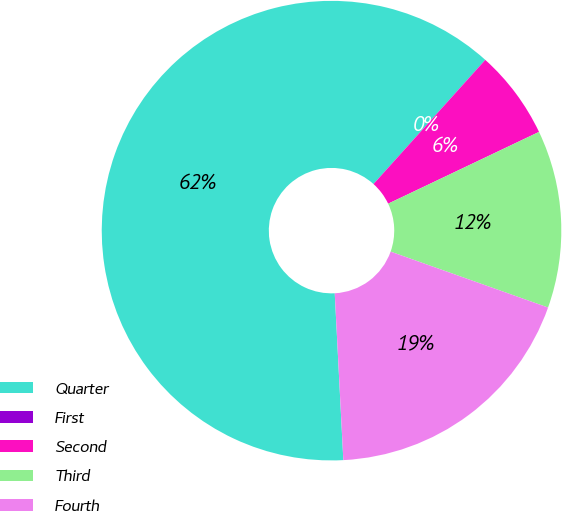Convert chart. <chart><loc_0><loc_0><loc_500><loc_500><pie_chart><fcel>Quarter<fcel>First<fcel>Second<fcel>Third<fcel>Fourth<nl><fcel>62.48%<fcel>0.01%<fcel>6.26%<fcel>12.5%<fcel>18.75%<nl></chart> 